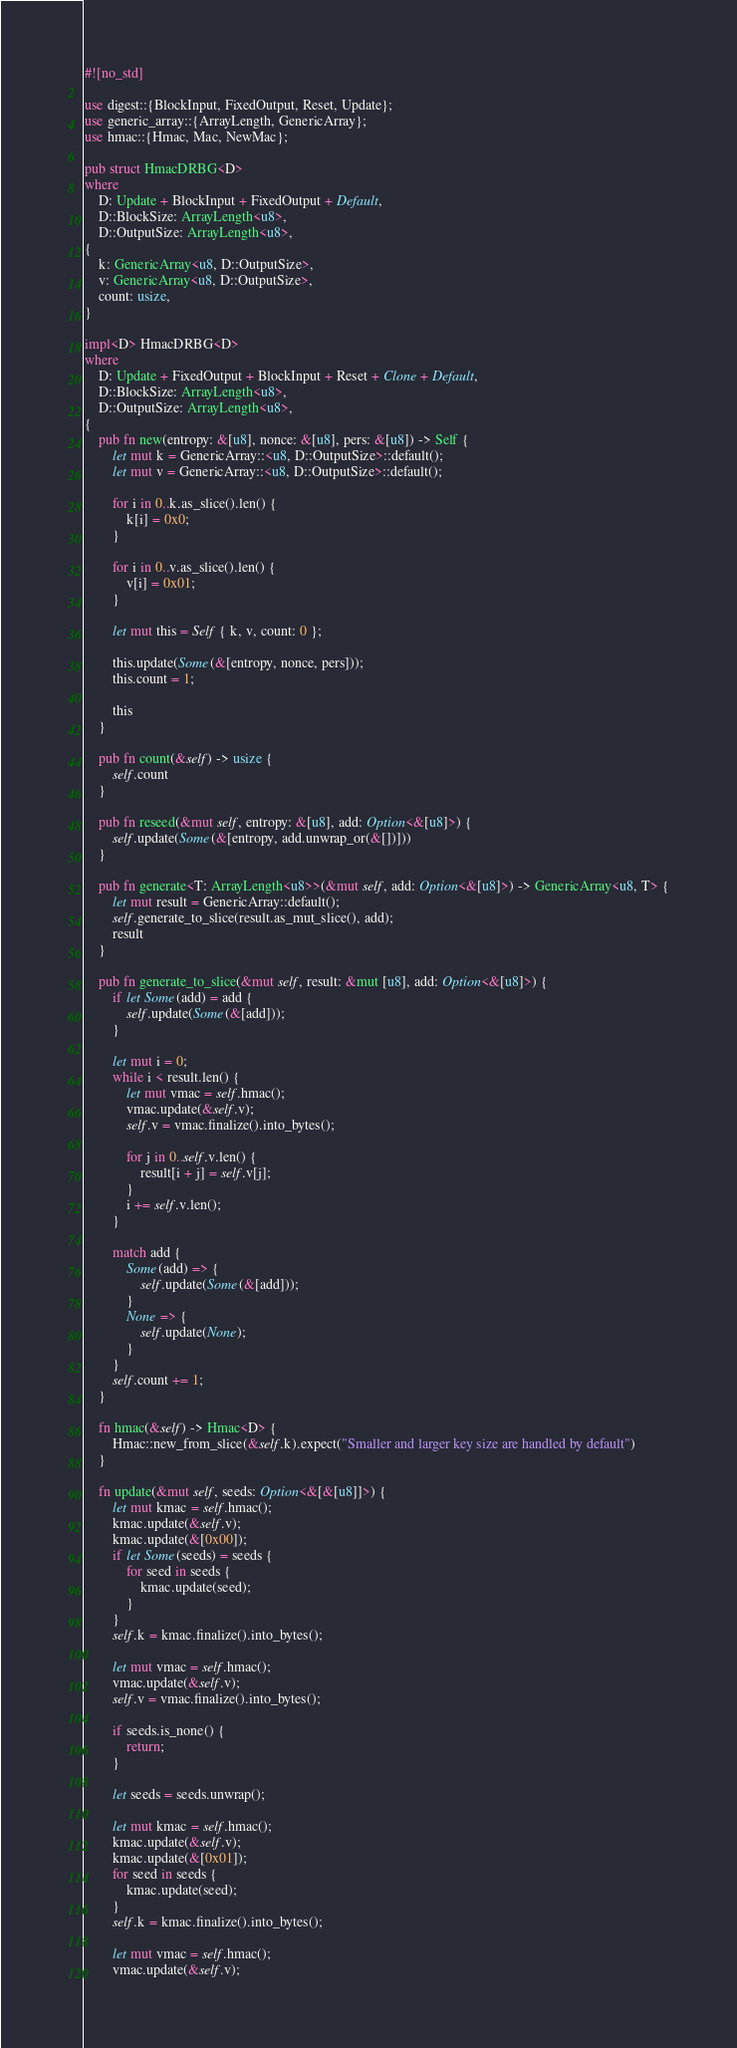<code> <loc_0><loc_0><loc_500><loc_500><_Rust_>#![no_std]

use digest::{BlockInput, FixedOutput, Reset, Update};
use generic_array::{ArrayLength, GenericArray};
use hmac::{Hmac, Mac, NewMac};

pub struct HmacDRBG<D>
where
    D: Update + BlockInput + FixedOutput + Default,
    D::BlockSize: ArrayLength<u8>,
    D::OutputSize: ArrayLength<u8>,
{
    k: GenericArray<u8, D::OutputSize>,
    v: GenericArray<u8, D::OutputSize>,
    count: usize,
}

impl<D> HmacDRBG<D>
where
    D: Update + FixedOutput + BlockInput + Reset + Clone + Default,
    D::BlockSize: ArrayLength<u8>,
    D::OutputSize: ArrayLength<u8>,
{
    pub fn new(entropy: &[u8], nonce: &[u8], pers: &[u8]) -> Self {
        let mut k = GenericArray::<u8, D::OutputSize>::default();
        let mut v = GenericArray::<u8, D::OutputSize>::default();

        for i in 0..k.as_slice().len() {
            k[i] = 0x0;
        }

        for i in 0..v.as_slice().len() {
            v[i] = 0x01;
        }

        let mut this = Self { k, v, count: 0 };

        this.update(Some(&[entropy, nonce, pers]));
        this.count = 1;

        this
    }

    pub fn count(&self) -> usize {
        self.count
    }

    pub fn reseed(&mut self, entropy: &[u8], add: Option<&[u8]>) {
        self.update(Some(&[entropy, add.unwrap_or(&[])]))
    }

    pub fn generate<T: ArrayLength<u8>>(&mut self, add: Option<&[u8]>) -> GenericArray<u8, T> {
        let mut result = GenericArray::default();
        self.generate_to_slice(result.as_mut_slice(), add);
        result
    }

    pub fn generate_to_slice(&mut self, result: &mut [u8], add: Option<&[u8]>) {
        if let Some(add) = add {
            self.update(Some(&[add]));
        }

        let mut i = 0;
        while i < result.len() {
            let mut vmac = self.hmac();
            vmac.update(&self.v);
            self.v = vmac.finalize().into_bytes();

            for j in 0..self.v.len() {
                result[i + j] = self.v[j];
            }
            i += self.v.len();
        }

        match add {
            Some(add) => {
                self.update(Some(&[add]));
            }
            None => {
                self.update(None);
            }
        }
        self.count += 1;
    }

    fn hmac(&self) -> Hmac<D> {
        Hmac::new_from_slice(&self.k).expect("Smaller and larger key size are handled by default")
    }

    fn update(&mut self, seeds: Option<&[&[u8]]>) {
        let mut kmac = self.hmac();
        kmac.update(&self.v);
        kmac.update(&[0x00]);
        if let Some(seeds) = seeds {
            for seed in seeds {
                kmac.update(seed);
            }
        }
        self.k = kmac.finalize().into_bytes();

        let mut vmac = self.hmac();
        vmac.update(&self.v);
        self.v = vmac.finalize().into_bytes();

        if seeds.is_none() {
            return;
        }

        let seeds = seeds.unwrap();

        let mut kmac = self.hmac();
        kmac.update(&self.v);
        kmac.update(&[0x01]);
        for seed in seeds {
            kmac.update(seed);
        }
        self.k = kmac.finalize().into_bytes();

        let mut vmac = self.hmac();
        vmac.update(&self.v);</code> 